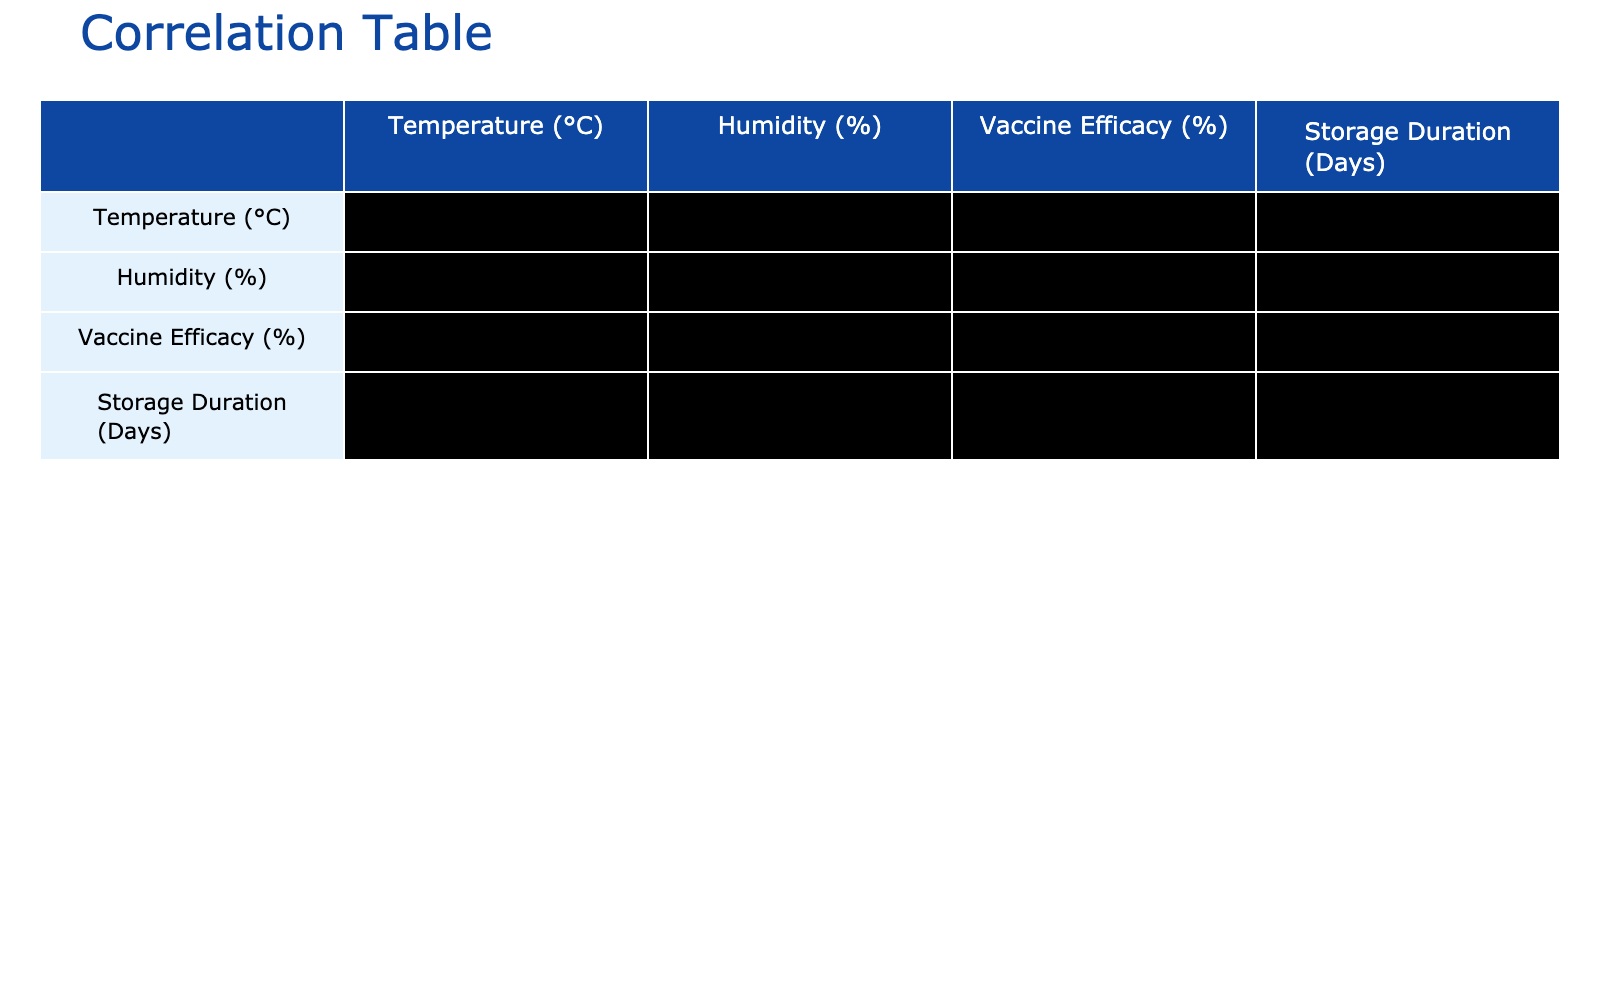What is the vaccine efficacy for Yellow Fever at 30 °C? The table lists the efficacy for Yellow Fever at a temperature of 30 °C, which is mentioned directly in the corresponding row. The efficacy is 50%.
Answer: 50% Which vaccine has the highest efficacy at the lowest temperature of 2 °C? The table shows that at 2 °C, the influenza vaccine has an efficacy of 95%, which is the highest among all listed vaccines at different temperatures.
Answer: 95% Calculate the average vaccine efficacy for temperatures 2 °C to 10 °C. The efficacies for these temperatures are 95%, 90%, 92%, 88%, and 85%. Summing these gives us 450%. Dividing by the number of vaccines (5), the average efficacy is 90%.
Answer: 90% Is the efficacy of the HPV vaccine lower than that of the COVID-19 vaccine? The HPV vaccine at 22 °C has an efficacy of 70%, while the COVID-19 vaccine at 20 °C has an efficacy of 75%. Since 70% is lower than 75%, the statement is true.
Answer: Yes What is the correlation between temperature and vaccine efficacy based on the table? The correlation value, which would be derived from the table, indicates the relationship between temperature and vaccine efficacy. In this case, if the correlation is negative (which we would expect based on general trends), it shows that as temperature increases, efficacy tends to decrease. Without a numerical value here, I can state the expected relationship.
Answer: Negative correlation 